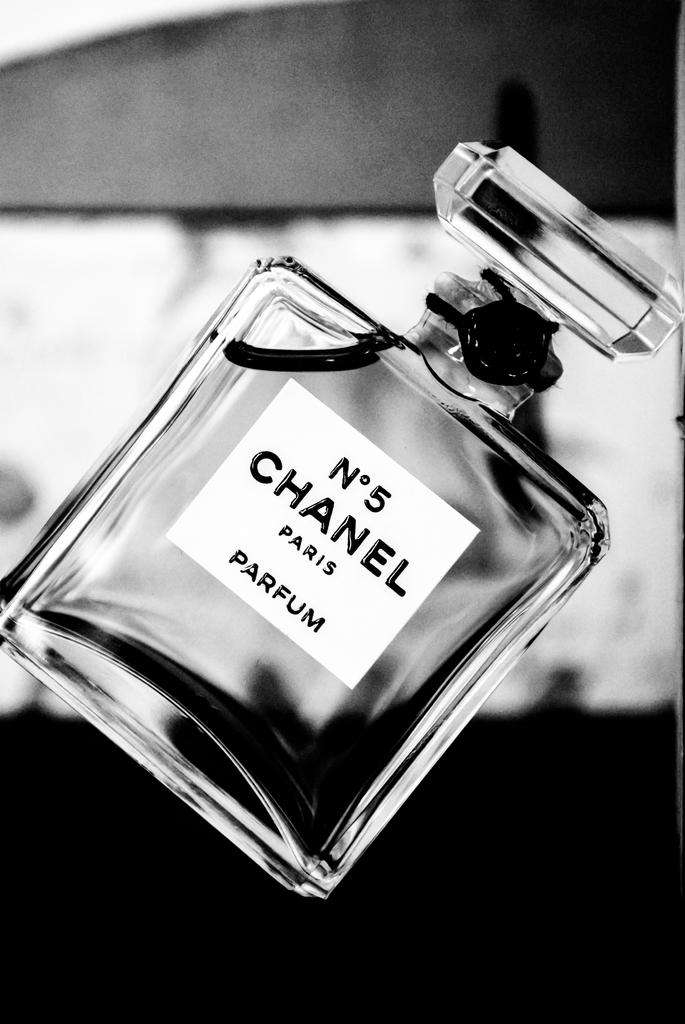<image>
Provide a brief description of the given image. a Chanel No 5 Paris Parfum bottle tilted 